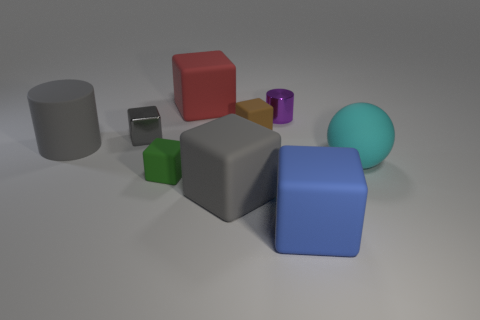Subtract all large red matte cubes. How many cubes are left? 5 Subtract all purple cylinders. How many cylinders are left? 1 Subtract 1 gray cylinders. How many objects are left? 8 Subtract all spheres. How many objects are left? 8 Subtract 3 cubes. How many cubes are left? 3 Subtract all yellow cylinders. Subtract all yellow cubes. How many cylinders are left? 2 Subtract all gray cylinders. How many green blocks are left? 1 Subtract all gray cylinders. Subtract all blue matte blocks. How many objects are left? 7 Add 8 big gray blocks. How many big gray blocks are left? 9 Add 6 small gray rubber balls. How many small gray rubber balls exist? 6 